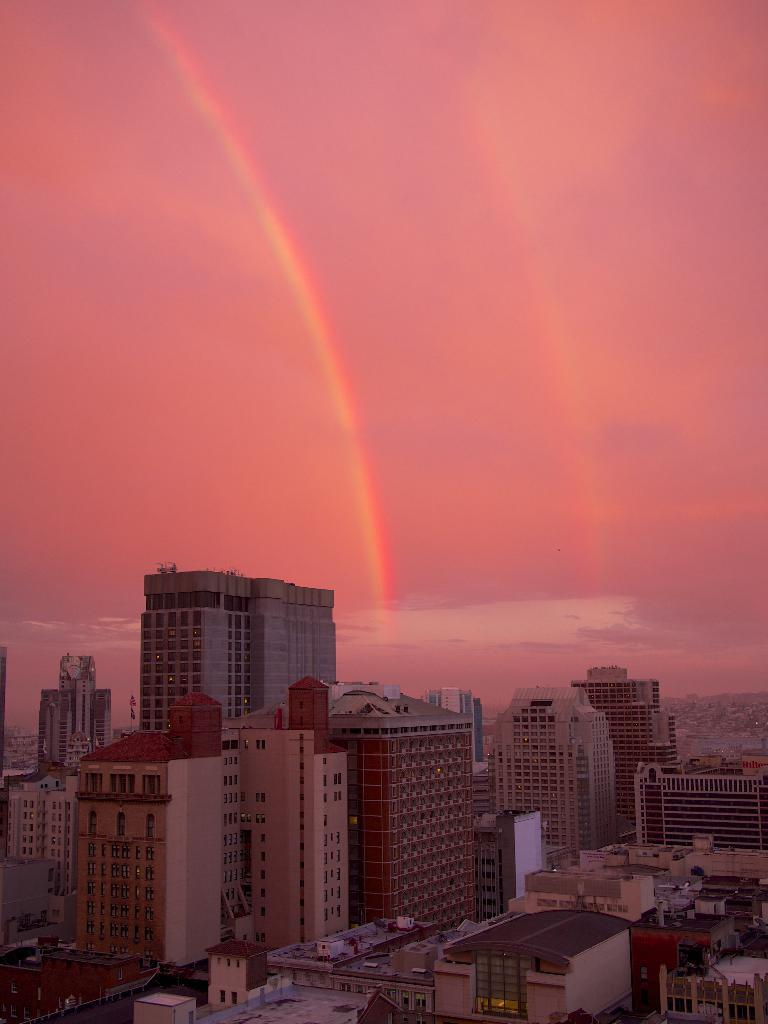What type of structures can be seen in the image? There are many buildings with windows in the image. What is visible in the background of the image? The sky is visible in the background of the image. What can be observed in the sky? Clouds are present in the sky. Can you tell me how many people are playing the game on the seashore in the image? There is no seashore, lake, or game present in the image. The image features buildings with windows and a sky with clouds. 